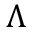<formula> <loc_0><loc_0><loc_500><loc_500>\Lambda</formula> 